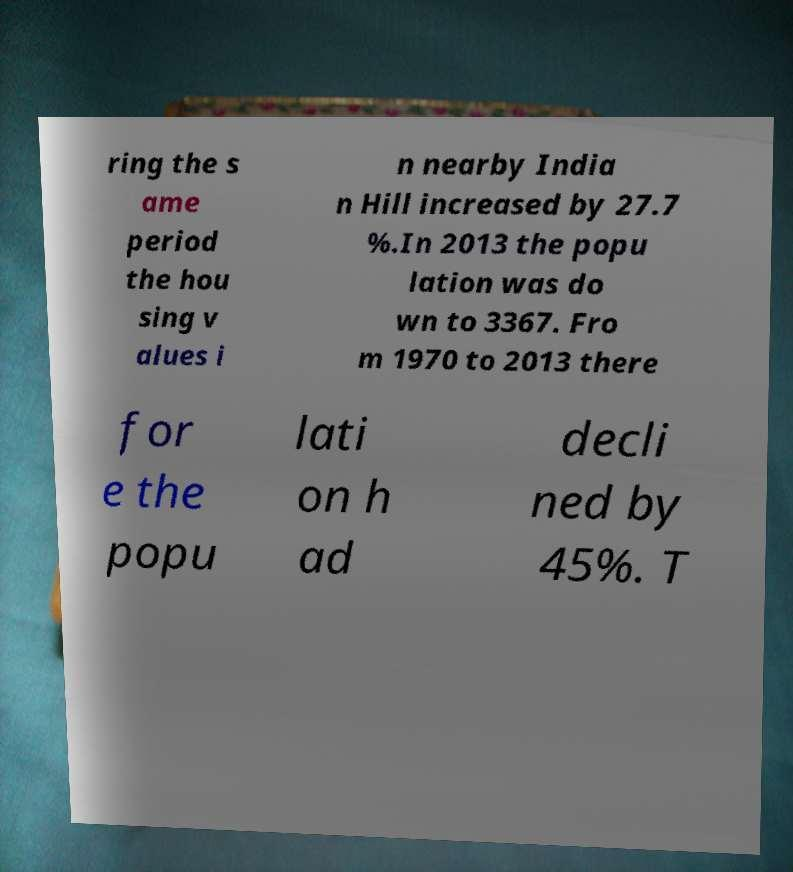Can you read and provide the text displayed in the image?This photo seems to have some interesting text. Can you extract and type it out for me? ring the s ame period the hou sing v alues i n nearby India n Hill increased by 27.7 %.In 2013 the popu lation was do wn to 3367. Fro m 1970 to 2013 there for e the popu lati on h ad decli ned by 45%. T 